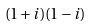Convert formula to latex. <formula><loc_0><loc_0><loc_500><loc_500>( 1 + i ) ( 1 - i )</formula> 